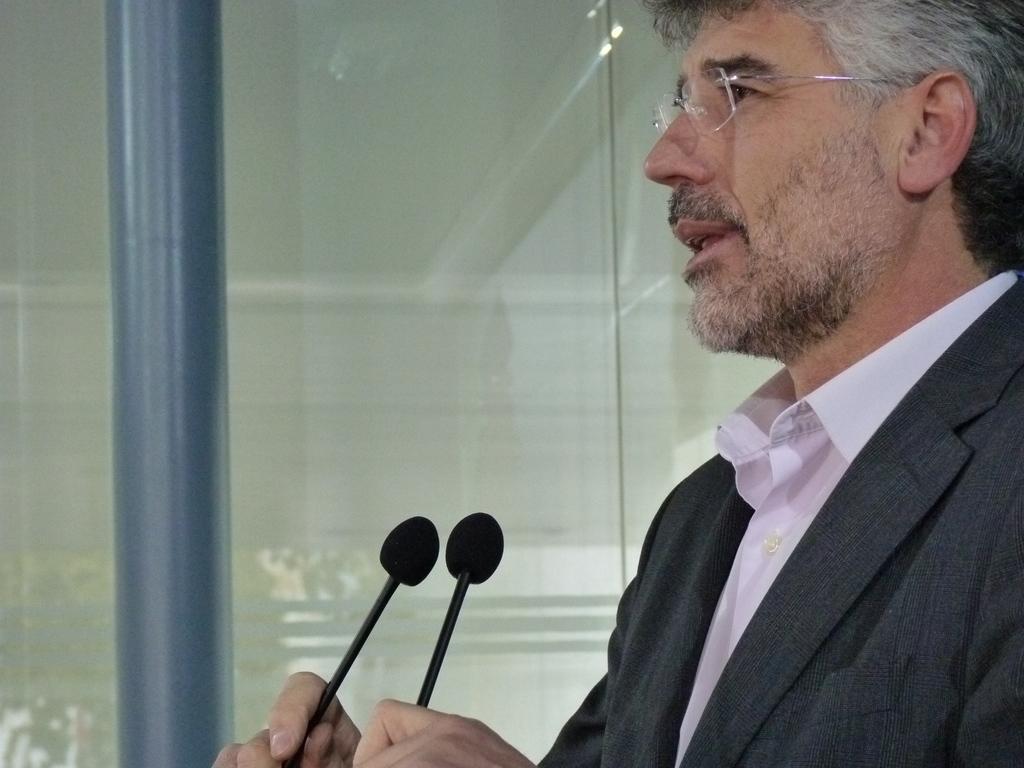In one or two sentences, can you explain what this image depicts? In this image there is a person holding a microphone. 